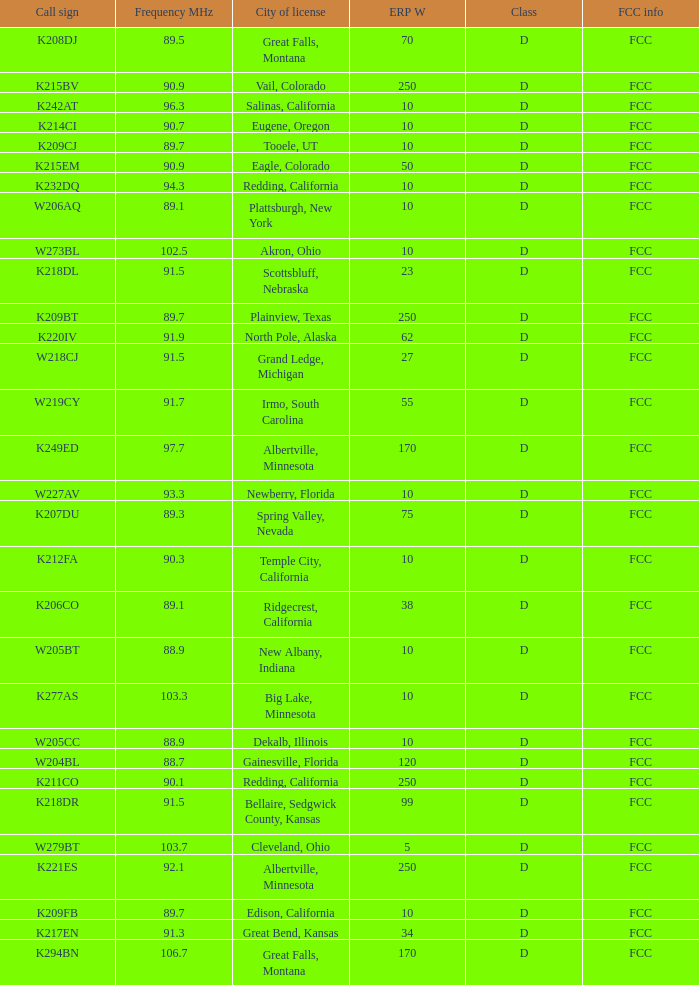What is the call sign of the translator with an ERP W greater than 38 and a city license from Great Falls, Montana? K294BN, K208DJ. Parse the full table. {'header': ['Call sign', 'Frequency MHz', 'City of license', 'ERP W', 'Class', 'FCC info'], 'rows': [['K208DJ', '89.5', 'Great Falls, Montana', '70', 'D', 'FCC'], ['K215BV', '90.9', 'Vail, Colorado', '250', 'D', 'FCC'], ['K242AT', '96.3', 'Salinas, California', '10', 'D', 'FCC'], ['K214CI', '90.7', 'Eugene, Oregon', '10', 'D', 'FCC'], ['K209CJ', '89.7', 'Tooele, UT', '10', 'D', 'FCC'], ['K215EM', '90.9', 'Eagle, Colorado', '50', 'D', 'FCC'], ['K232DQ', '94.3', 'Redding, California', '10', 'D', 'FCC'], ['W206AQ', '89.1', 'Plattsburgh, New York', '10', 'D', 'FCC'], ['W273BL', '102.5', 'Akron, Ohio', '10', 'D', 'FCC'], ['K218DL', '91.5', 'Scottsbluff, Nebraska', '23', 'D', 'FCC'], ['K209BT', '89.7', 'Plainview, Texas', '250', 'D', 'FCC'], ['K220IV', '91.9', 'North Pole, Alaska', '62', 'D', 'FCC'], ['W218CJ', '91.5', 'Grand Ledge, Michigan', '27', 'D', 'FCC'], ['W219CY', '91.7', 'Irmo, South Carolina', '55', 'D', 'FCC'], ['K249ED', '97.7', 'Albertville, Minnesota', '170', 'D', 'FCC'], ['W227AV', '93.3', 'Newberry, Florida', '10', 'D', 'FCC'], ['K207DU', '89.3', 'Spring Valley, Nevada', '75', 'D', 'FCC'], ['K212FA', '90.3', 'Temple City, California', '10', 'D', 'FCC'], ['K206CO', '89.1', 'Ridgecrest, California', '38', 'D', 'FCC'], ['W205BT', '88.9', 'New Albany, Indiana', '10', 'D', 'FCC'], ['K277AS', '103.3', 'Big Lake, Minnesota', '10', 'D', 'FCC'], ['W205CC', '88.9', 'Dekalb, Illinois', '10', 'D', 'FCC'], ['W204BL', '88.7', 'Gainesville, Florida', '120', 'D', 'FCC'], ['K211CO', '90.1', 'Redding, California', '250', 'D', 'FCC'], ['K218DR', '91.5', 'Bellaire, Sedgwick County, Kansas', '99', 'D', 'FCC'], ['W279BT', '103.7', 'Cleveland, Ohio', '5', 'D', 'FCC'], ['K221ES', '92.1', 'Albertville, Minnesota', '250', 'D', 'FCC'], ['K209FB', '89.7', 'Edison, California', '10', 'D', 'FCC'], ['K217EN', '91.3', 'Great Bend, Kansas', '34', 'D', 'FCC'], ['K294BN', '106.7', 'Great Falls, Montana', '170', 'D', 'FCC']]} 